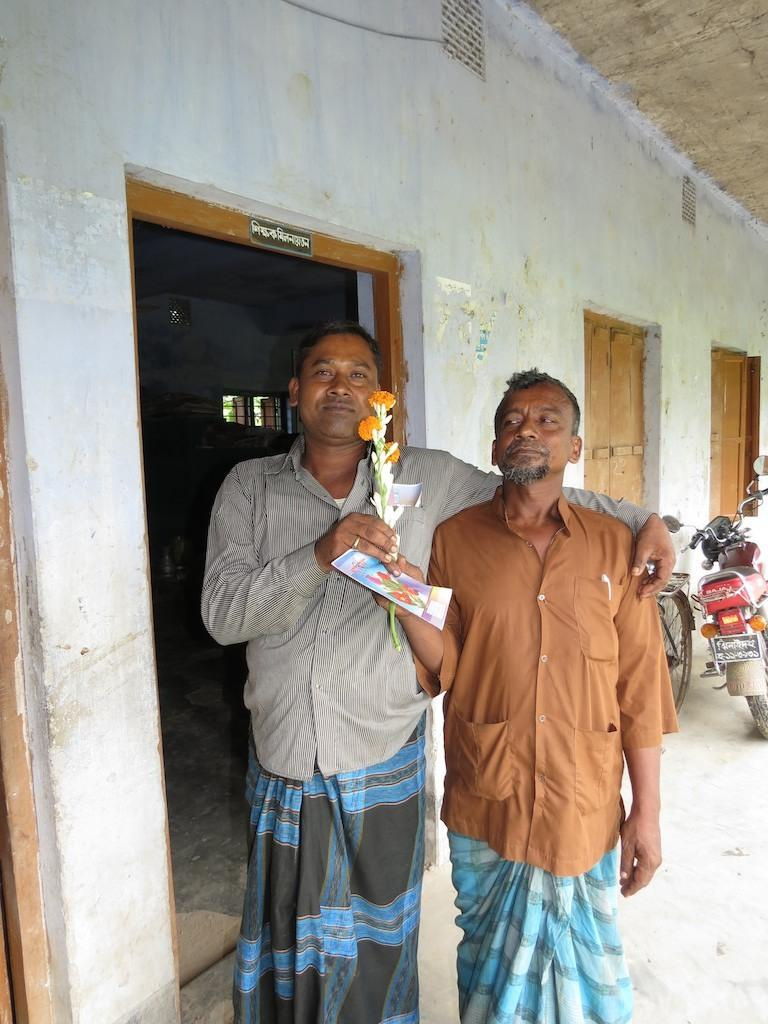How many people are in the image? There are two men in the image. What are the men holding in the image? The men are holding a card. What can be seen in the image besides the men and the card? There is a flower bouquet, a bicycle, a bike, and a wall with windows in the background of the image. What type of pipe can be seen connecting the two men in the image? There is no pipe connecting the two men in the image. 